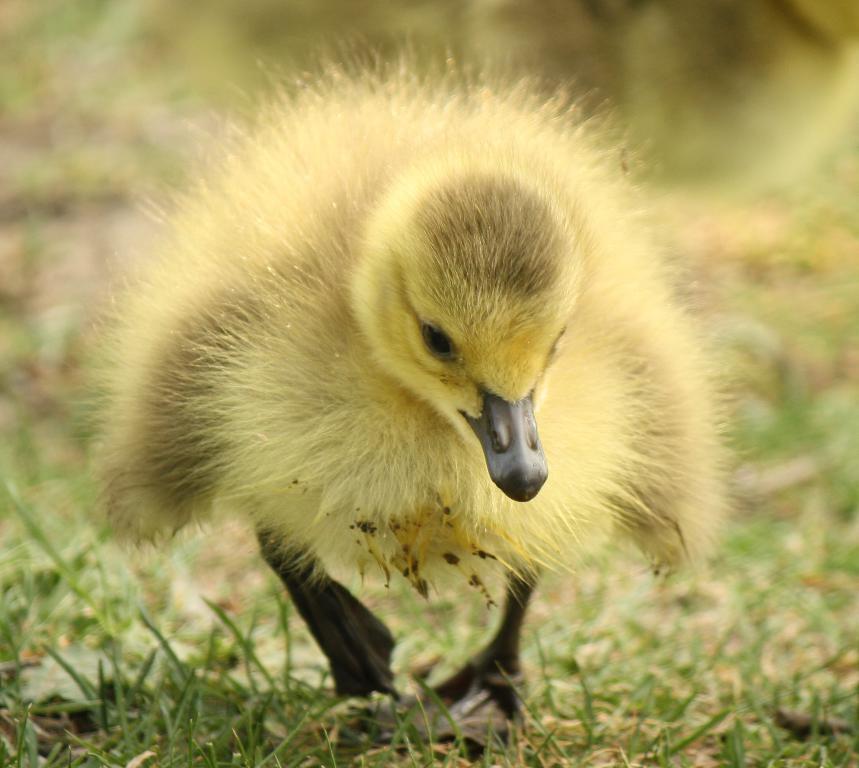Describe this image in one or two sentences. In this picture we can see an animal on the ground and in the background we can see grass and it is blurry. 